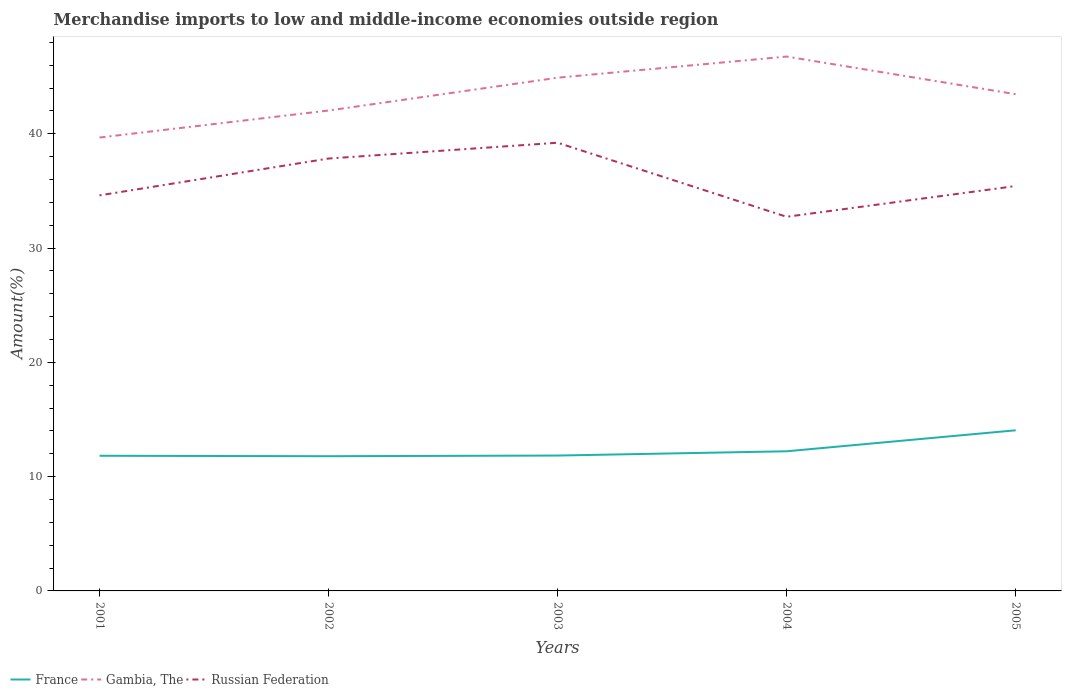Does the line corresponding to Russian Federation intersect with the line corresponding to Gambia, The?
Offer a terse response. No. Is the number of lines equal to the number of legend labels?
Offer a very short reply. Yes. Across all years, what is the maximum percentage of amount earned from merchandise imports in France?
Offer a very short reply. 11.79. What is the total percentage of amount earned from merchandise imports in Russian Federation in the graph?
Provide a short and direct response. -1.38. What is the difference between the highest and the second highest percentage of amount earned from merchandise imports in France?
Your answer should be very brief. 2.27. Are the values on the major ticks of Y-axis written in scientific E-notation?
Make the answer very short. No. How many legend labels are there?
Provide a succinct answer. 3. What is the title of the graph?
Your response must be concise. Merchandise imports to low and middle-income economies outside region. What is the label or title of the Y-axis?
Make the answer very short. Amount(%). What is the Amount(%) of France in 2001?
Provide a short and direct response. 11.82. What is the Amount(%) in Gambia, The in 2001?
Provide a succinct answer. 39.67. What is the Amount(%) in Russian Federation in 2001?
Keep it short and to the point. 34.61. What is the Amount(%) in France in 2002?
Your answer should be very brief. 11.79. What is the Amount(%) of Gambia, The in 2002?
Give a very brief answer. 42.03. What is the Amount(%) of Russian Federation in 2002?
Keep it short and to the point. 37.83. What is the Amount(%) in France in 2003?
Ensure brevity in your answer.  11.84. What is the Amount(%) in Gambia, The in 2003?
Provide a succinct answer. 44.9. What is the Amount(%) in Russian Federation in 2003?
Your answer should be compact. 39.21. What is the Amount(%) of France in 2004?
Ensure brevity in your answer.  12.22. What is the Amount(%) in Gambia, The in 2004?
Provide a short and direct response. 46.75. What is the Amount(%) in Russian Federation in 2004?
Your answer should be compact. 32.73. What is the Amount(%) in France in 2005?
Offer a very short reply. 14.05. What is the Amount(%) of Gambia, The in 2005?
Ensure brevity in your answer.  43.46. What is the Amount(%) in Russian Federation in 2005?
Make the answer very short. 35.42. Across all years, what is the maximum Amount(%) in France?
Offer a terse response. 14.05. Across all years, what is the maximum Amount(%) in Gambia, The?
Your answer should be very brief. 46.75. Across all years, what is the maximum Amount(%) in Russian Federation?
Ensure brevity in your answer.  39.21. Across all years, what is the minimum Amount(%) of France?
Offer a very short reply. 11.79. Across all years, what is the minimum Amount(%) of Gambia, The?
Your response must be concise. 39.67. Across all years, what is the minimum Amount(%) of Russian Federation?
Provide a succinct answer. 32.73. What is the total Amount(%) of France in the graph?
Keep it short and to the point. 61.73. What is the total Amount(%) of Gambia, The in the graph?
Give a very brief answer. 216.81. What is the total Amount(%) of Russian Federation in the graph?
Your response must be concise. 179.81. What is the difference between the Amount(%) of France in 2001 and that in 2002?
Your answer should be compact. 0.04. What is the difference between the Amount(%) in Gambia, The in 2001 and that in 2002?
Keep it short and to the point. -2.36. What is the difference between the Amount(%) in Russian Federation in 2001 and that in 2002?
Your response must be concise. -3.22. What is the difference between the Amount(%) in France in 2001 and that in 2003?
Offer a terse response. -0.02. What is the difference between the Amount(%) of Gambia, The in 2001 and that in 2003?
Give a very brief answer. -5.23. What is the difference between the Amount(%) of Russian Federation in 2001 and that in 2003?
Ensure brevity in your answer.  -4.6. What is the difference between the Amount(%) in France in 2001 and that in 2004?
Make the answer very short. -0.39. What is the difference between the Amount(%) of Gambia, The in 2001 and that in 2004?
Offer a very short reply. -7.08. What is the difference between the Amount(%) in Russian Federation in 2001 and that in 2004?
Give a very brief answer. 1.87. What is the difference between the Amount(%) in France in 2001 and that in 2005?
Provide a short and direct response. -2.23. What is the difference between the Amount(%) in Gambia, The in 2001 and that in 2005?
Offer a very short reply. -3.79. What is the difference between the Amount(%) of Russian Federation in 2001 and that in 2005?
Provide a short and direct response. -0.82. What is the difference between the Amount(%) in France in 2002 and that in 2003?
Keep it short and to the point. -0.06. What is the difference between the Amount(%) in Gambia, The in 2002 and that in 2003?
Your answer should be compact. -2.87. What is the difference between the Amount(%) in Russian Federation in 2002 and that in 2003?
Keep it short and to the point. -1.38. What is the difference between the Amount(%) of France in 2002 and that in 2004?
Give a very brief answer. -0.43. What is the difference between the Amount(%) of Gambia, The in 2002 and that in 2004?
Keep it short and to the point. -4.72. What is the difference between the Amount(%) in Russian Federation in 2002 and that in 2004?
Make the answer very short. 5.1. What is the difference between the Amount(%) in France in 2002 and that in 2005?
Keep it short and to the point. -2.27. What is the difference between the Amount(%) of Gambia, The in 2002 and that in 2005?
Give a very brief answer. -1.43. What is the difference between the Amount(%) of Russian Federation in 2002 and that in 2005?
Offer a terse response. 2.41. What is the difference between the Amount(%) in France in 2003 and that in 2004?
Keep it short and to the point. -0.37. What is the difference between the Amount(%) in Gambia, The in 2003 and that in 2004?
Make the answer very short. -1.85. What is the difference between the Amount(%) in Russian Federation in 2003 and that in 2004?
Offer a terse response. 6.48. What is the difference between the Amount(%) in France in 2003 and that in 2005?
Your answer should be compact. -2.21. What is the difference between the Amount(%) of Gambia, The in 2003 and that in 2005?
Make the answer very short. 1.44. What is the difference between the Amount(%) in Russian Federation in 2003 and that in 2005?
Keep it short and to the point. 3.79. What is the difference between the Amount(%) in France in 2004 and that in 2005?
Make the answer very short. -1.84. What is the difference between the Amount(%) in Gambia, The in 2004 and that in 2005?
Offer a very short reply. 3.29. What is the difference between the Amount(%) of Russian Federation in 2004 and that in 2005?
Offer a very short reply. -2.69. What is the difference between the Amount(%) of France in 2001 and the Amount(%) of Gambia, The in 2002?
Offer a terse response. -30.21. What is the difference between the Amount(%) in France in 2001 and the Amount(%) in Russian Federation in 2002?
Your answer should be compact. -26.01. What is the difference between the Amount(%) in Gambia, The in 2001 and the Amount(%) in Russian Federation in 2002?
Your response must be concise. 1.84. What is the difference between the Amount(%) of France in 2001 and the Amount(%) of Gambia, The in 2003?
Your answer should be very brief. -33.08. What is the difference between the Amount(%) in France in 2001 and the Amount(%) in Russian Federation in 2003?
Ensure brevity in your answer.  -27.39. What is the difference between the Amount(%) in Gambia, The in 2001 and the Amount(%) in Russian Federation in 2003?
Your answer should be very brief. 0.45. What is the difference between the Amount(%) of France in 2001 and the Amount(%) of Gambia, The in 2004?
Ensure brevity in your answer.  -34.93. What is the difference between the Amount(%) of France in 2001 and the Amount(%) of Russian Federation in 2004?
Offer a very short reply. -20.91. What is the difference between the Amount(%) in Gambia, The in 2001 and the Amount(%) in Russian Federation in 2004?
Keep it short and to the point. 6.93. What is the difference between the Amount(%) of France in 2001 and the Amount(%) of Gambia, The in 2005?
Offer a terse response. -31.63. What is the difference between the Amount(%) in France in 2001 and the Amount(%) in Russian Federation in 2005?
Your answer should be compact. -23.6. What is the difference between the Amount(%) of Gambia, The in 2001 and the Amount(%) of Russian Federation in 2005?
Offer a very short reply. 4.24. What is the difference between the Amount(%) of France in 2002 and the Amount(%) of Gambia, The in 2003?
Make the answer very short. -33.11. What is the difference between the Amount(%) in France in 2002 and the Amount(%) in Russian Federation in 2003?
Your answer should be very brief. -27.42. What is the difference between the Amount(%) in Gambia, The in 2002 and the Amount(%) in Russian Federation in 2003?
Give a very brief answer. 2.82. What is the difference between the Amount(%) of France in 2002 and the Amount(%) of Gambia, The in 2004?
Your answer should be compact. -34.96. What is the difference between the Amount(%) of France in 2002 and the Amount(%) of Russian Federation in 2004?
Provide a succinct answer. -20.95. What is the difference between the Amount(%) of Gambia, The in 2002 and the Amount(%) of Russian Federation in 2004?
Provide a succinct answer. 9.3. What is the difference between the Amount(%) in France in 2002 and the Amount(%) in Gambia, The in 2005?
Ensure brevity in your answer.  -31.67. What is the difference between the Amount(%) in France in 2002 and the Amount(%) in Russian Federation in 2005?
Provide a succinct answer. -23.64. What is the difference between the Amount(%) of Gambia, The in 2002 and the Amount(%) of Russian Federation in 2005?
Your response must be concise. 6.61. What is the difference between the Amount(%) in France in 2003 and the Amount(%) in Gambia, The in 2004?
Provide a short and direct response. -34.91. What is the difference between the Amount(%) of France in 2003 and the Amount(%) of Russian Federation in 2004?
Ensure brevity in your answer.  -20.89. What is the difference between the Amount(%) of Gambia, The in 2003 and the Amount(%) of Russian Federation in 2004?
Offer a very short reply. 12.17. What is the difference between the Amount(%) of France in 2003 and the Amount(%) of Gambia, The in 2005?
Ensure brevity in your answer.  -31.61. What is the difference between the Amount(%) in France in 2003 and the Amount(%) in Russian Federation in 2005?
Provide a short and direct response. -23.58. What is the difference between the Amount(%) of Gambia, The in 2003 and the Amount(%) of Russian Federation in 2005?
Make the answer very short. 9.48. What is the difference between the Amount(%) in France in 2004 and the Amount(%) in Gambia, The in 2005?
Make the answer very short. -31.24. What is the difference between the Amount(%) in France in 2004 and the Amount(%) in Russian Federation in 2005?
Offer a very short reply. -23.21. What is the difference between the Amount(%) in Gambia, The in 2004 and the Amount(%) in Russian Federation in 2005?
Offer a terse response. 11.33. What is the average Amount(%) in France per year?
Your answer should be compact. 12.35. What is the average Amount(%) of Gambia, The per year?
Your answer should be compact. 43.36. What is the average Amount(%) of Russian Federation per year?
Your response must be concise. 35.96. In the year 2001, what is the difference between the Amount(%) in France and Amount(%) in Gambia, The?
Offer a terse response. -27.84. In the year 2001, what is the difference between the Amount(%) of France and Amount(%) of Russian Federation?
Ensure brevity in your answer.  -22.78. In the year 2001, what is the difference between the Amount(%) of Gambia, The and Amount(%) of Russian Federation?
Your answer should be compact. 5.06. In the year 2002, what is the difference between the Amount(%) of France and Amount(%) of Gambia, The?
Your response must be concise. -30.24. In the year 2002, what is the difference between the Amount(%) of France and Amount(%) of Russian Federation?
Give a very brief answer. -26.04. In the year 2002, what is the difference between the Amount(%) in Gambia, The and Amount(%) in Russian Federation?
Make the answer very short. 4.2. In the year 2003, what is the difference between the Amount(%) in France and Amount(%) in Gambia, The?
Provide a succinct answer. -33.06. In the year 2003, what is the difference between the Amount(%) of France and Amount(%) of Russian Federation?
Provide a succinct answer. -27.37. In the year 2003, what is the difference between the Amount(%) in Gambia, The and Amount(%) in Russian Federation?
Your answer should be compact. 5.69. In the year 2004, what is the difference between the Amount(%) in France and Amount(%) in Gambia, The?
Your answer should be very brief. -34.54. In the year 2004, what is the difference between the Amount(%) in France and Amount(%) in Russian Federation?
Keep it short and to the point. -20.52. In the year 2004, what is the difference between the Amount(%) of Gambia, The and Amount(%) of Russian Federation?
Offer a terse response. 14.02. In the year 2005, what is the difference between the Amount(%) of France and Amount(%) of Gambia, The?
Offer a terse response. -29.4. In the year 2005, what is the difference between the Amount(%) of France and Amount(%) of Russian Federation?
Your response must be concise. -21.37. In the year 2005, what is the difference between the Amount(%) in Gambia, The and Amount(%) in Russian Federation?
Ensure brevity in your answer.  8.03. What is the ratio of the Amount(%) of Gambia, The in 2001 to that in 2002?
Give a very brief answer. 0.94. What is the ratio of the Amount(%) in Russian Federation in 2001 to that in 2002?
Make the answer very short. 0.91. What is the ratio of the Amount(%) in France in 2001 to that in 2003?
Offer a terse response. 1. What is the ratio of the Amount(%) in Gambia, The in 2001 to that in 2003?
Make the answer very short. 0.88. What is the ratio of the Amount(%) in Russian Federation in 2001 to that in 2003?
Your answer should be compact. 0.88. What is the ratio of the Amount(%) of France in 2001 to that in 2004?
Offer a very short reply. 0.97. What is the ratio of the Amount(%) in Gambia, The in 2001 to that in 2004?
Give a very brief answer. 0.85. What is the ratio of the Amount(%) of Russian Federation in 2001 to that in 2004?
Give a very brief answer. 1.06. What is the ratio of the Amount(%) of France in 2001 to that in 2005?
Provide a short and direct response. 0.84. What is the ratio of the Amount(%) in Gambia, The in 2001 to that in 2005?
Give a very brief answer. 0.91. What is the ratio of the Amount(%) of Russian Federation in 2001 to that in 2005?
Your response must be concise. 0.98. What is the ratio of the Amount(%) of France in 2002 to that in 2003?
Make the answer very short. 1. What is the ratio of the Amount(%) of Gambia, The in 2002 to that in 2003?
Offer a very short reply. 0.94. What is the ratio of the Amount(%) in Russian Federation in 2002 to that in 2003?
Provide a succinct answer. 0.96. What is the ratio of the Amount(%) of France in 2002 to that in 2004?
Keep it short and to the point. 0.96. What is the ratio of the Amount(%) of Gambia, The in 2002 to that in 2004?
Provide a short and direct response. 0.9. What is the ratio of the Amount(%) in Russian Federation in 2002 to that in 2004?
Offer a very short reply. 1.16. What is the ratio of the Amount(%) of France in 2002 to that in 2005?
Offer a terse response. 0.84. What is the ratio of the Amount(%) in Gambia, The in 2002 to that in 2005?
Provide a succinct answer. 0.97. What is the ratio of the Amount(%) of Russian Federation in 2002 to that in 2005?
Ensure brevity in your answer.  1.07. What is the ratio of the Amount(%) of France in 2003 to that in 2004?
Provide a short and direct response. 0.97. What is the ratio of the Amount(%) in Gambia, The in 2003 to that in 2004?
Your response must be concise. 0.96. What is the ratio of the Amount(%) of Russian Federation in 2003 to that in 2004?
Keep it short and to the point. 1.2. What is the ratio of the Amount(%) of France in 2003 to that in 2005?
Your response must be concise. 0.84. What is the ratio of the Amount(%) in Gambia, The in 2003 to that in 2005?
Give a very brief answer. 1.03. What is the ratio of the Amount(%) in Russian Federation in 2003 to that in 2005?
Offer a terse response. 1.11. What is the ratio of the Amount(%) in France in 2004 to that in 2005?
Keep it short and to the point. 0.87. What is the ratio of the Amount(%) in Gambia, The in 2004 to that in 2005?
Offer a terse response. 1.08. What is the ratio of the Amount(%) in Russian Federation in 2004 to that in 2005?
Offer a very short reply. 0.92. What is the difference between the highest and the second highest Amount(%) in France?
Offer a very short reply. 1.84. What is the difference between the highest and the second highest Amount(%) of Gambia, The?
Keep it short and to the point. 1.85. What is the difference between the highest and the second highest Amount(%) of Russian Federation?
Give a very brief answer. 1.38. What is the difference between the highest and the lowest Amount(%) in France?
Your answer should be very brief. 2.27. What is the difference between the highest and the lowest Amount(%) in Gambia, The?
Make the answer very short. 7.08. What is the difference between the highest and the lowest Amount(%) in Russian Federation?
Give a very brief answer. 6.48. 